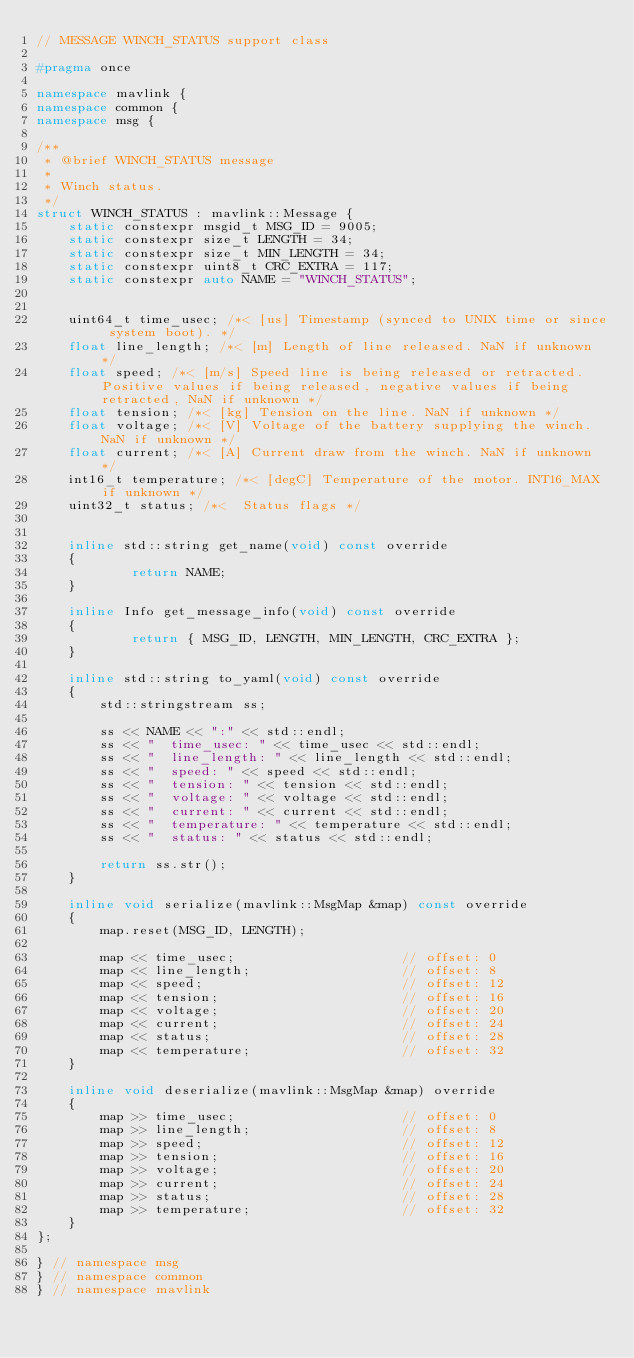Convert code to text. <code><loc_0><loc_0><loc_500><loc_500><_C++_>// MESSAGE WINCH_STATUS support class

#pragma once

namespace mavlink {
namespace common {
namespace msg {

/**
 * @brief WINCH_STATUS message
 *
 * Winch status.
 */
struct WINCH_STATUS : mavlink::Message {
    static constexpr msgid_t MSG_ID = 9005;
    static constexpr size_t LENGTH = 34;
    static constexpr size_t MIN_LENGTH = 34;
    static constexpr uint8_t CRC_EXTRA = 117;
    static constexpr auto NAME = "WINCH_STATUS";


    uint64_t time_usec; /*< [us] Timestamp (synced to UNIX time or since system boot). */
    float line_length; /*< [m] Length of line released. NaN if unknown */
    float speed; /*< [m/s] Speed line is being released or retracted. Positive values if being released, negative values if being retracted, NaN if unknown */
    float tension; /*< [kg] Tension on the line. NaN if unknown */
    float voltage; /*< [V] Voltage of the battery supplying the winch. NaN if unknown */
    float current; /*< [A] Current draw from the winch. NaN if unknown */
    int16_t temperature; /*< [degC] Temperature of the motor. INT16_MAX if unknown */
    uint32_t status; /*<  Status flags */


    inline std::string get_name(void) const override
    {
            return NAME;
    }

    inline Info get_message_info(void) const override
    {
            return { MSG_ID, LENGTH, MIN_LENGTH, CRC_EXTRA };
    }

    inline std::string to_yaml(void) const override
    {
        std::stringstream ss;

        ss << NAME << ":" << std::endl;
        ss << "  time_usec: " << time_usec << std::endl;
        ss << "  line_length: " << line_length << std::endl;
        ss << "  speed: " << speed << std::endl;
        ss << "  tension: " << tension << std::endl;
        ss << "  voltage: " << voltage << std::endl;
        ss << "  current: " << current << std::endl;
        ss << "  temperature: " << temperature << std::endl;
        ss << "  status: " << status << std::endl;

        return ss.str();
    }

    inline void serialize(mavlink::MsgMap &map) const override
    {
        map.reset(MSG_ID, LENGTH);

        map << time_usec;                     // offset: 0
        map << line_length;                   // offset: 8
        map << speed;                         // offset: 12
        map << tension;                       // offset: 16
        map << voltage;                       // offset: 20
        map << current;                       // offset: 24
        map << status;                        // offset: 28
        map << temperature;                   // offset: 32
    }

    inline void deserialize(mavlink::MsgMap &map) override
    {
        map >> time_usec;                     // offset: 0
        map >> line_length;                   // offset: 8
        map >> speed;                         // offset: 12
        map >> tension;                       // offset: 16
        map >> voltage;                       // offset: 20
        map >> current;                       // offset: 24
        map >> status;                        // offset: 28
        map >> temperature;                   // offset: 32
    }
};

} // namespace msg
} // namespace common
} // namespace mavlink
</code> 